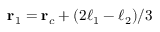Convert formula to latex. <formula><loc_0><loc_0><loc_500><loc_500>r _ { 1 } = r _ { c } + ( 2 \ell _ { 1 } - \ell _ { 2 } ) / 3</formula> 